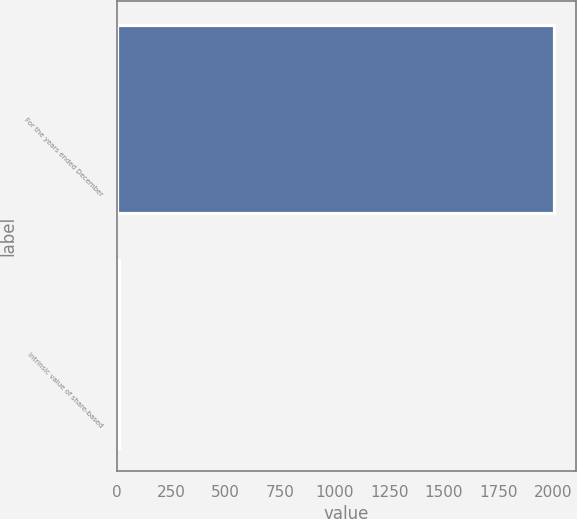<chart> <loc_0><loc_0><loc_500><loc_500><bar_chart><fcel>For the years ended December<fcel>Intrinsic value of share-based<nl><fcel>2005<fcel>12.4<nl></chart> 